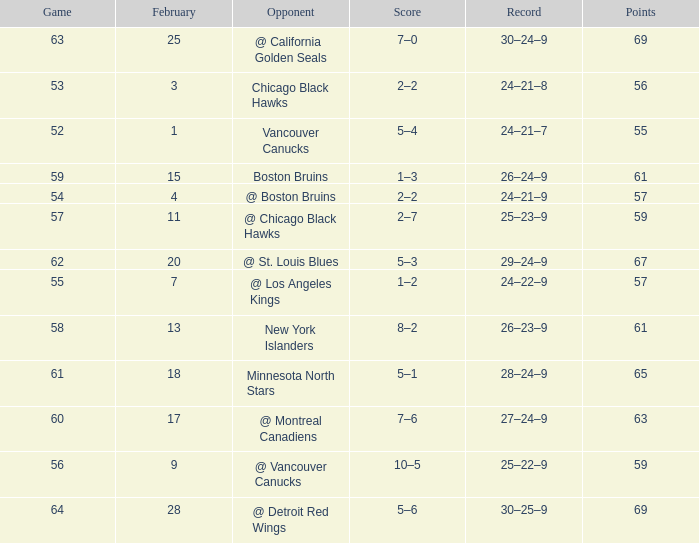Which opponent has a game larger than 61, february smaller than 28, and fewer points than 69? @ St. Louis Blues. 